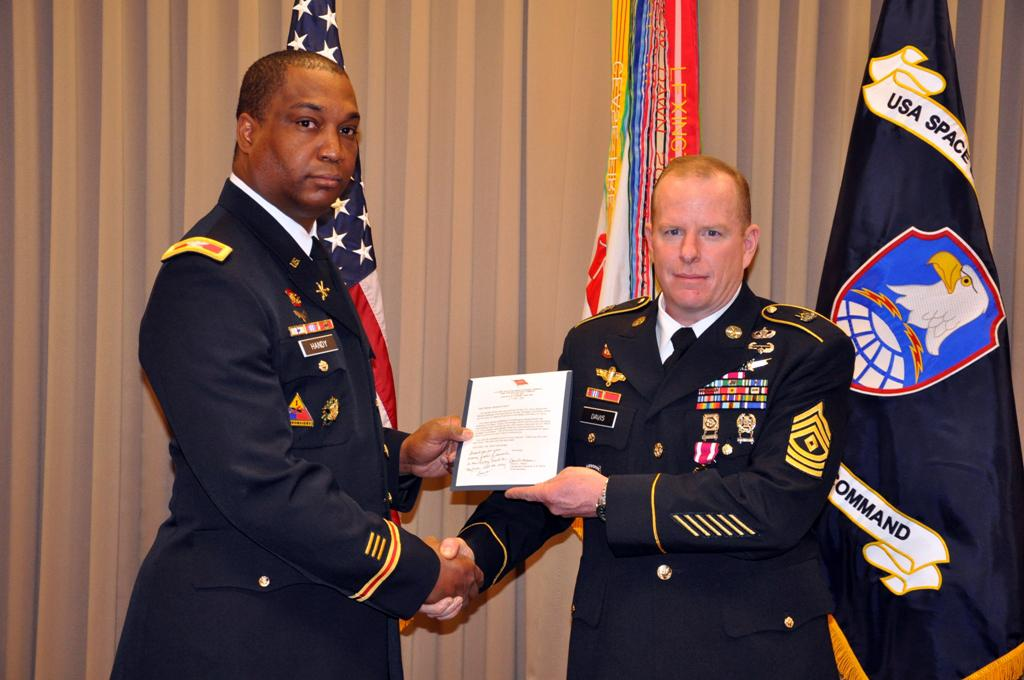<image>
Write a terse but informative summary of the picture. Two men holding a piece of paper, the words USA space are visible in the background. 